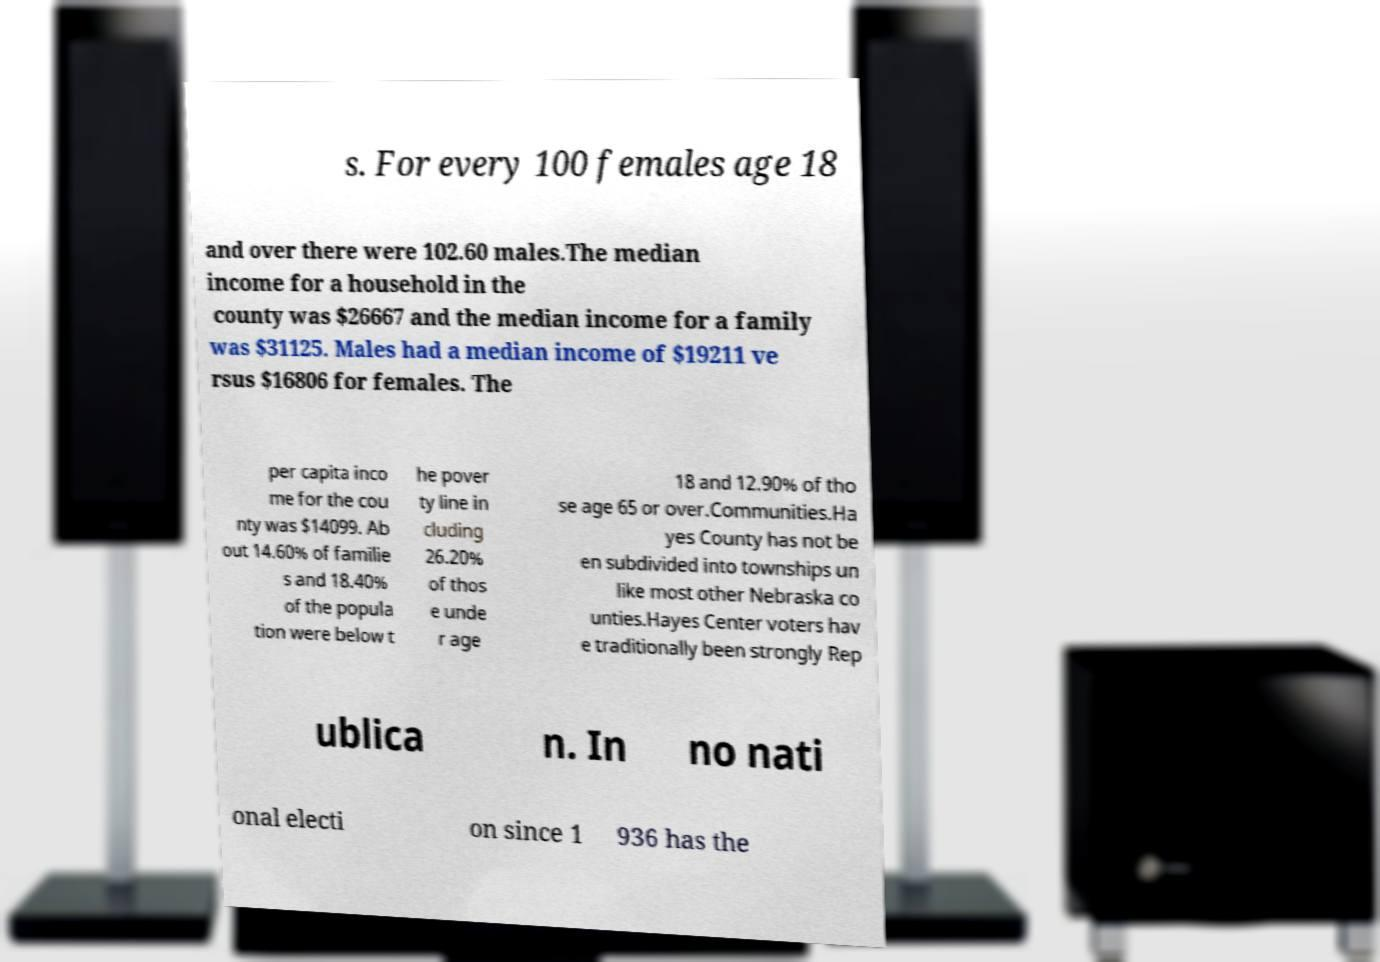Can you read and provide the text displayed in the image?This photo seems to have some interesting text. Can you extract and type it out for me? s. For every 100 females age 18 and over there were 102.60 males.The median income for a household in the county was $26667 and the median income for a family was $31125. Males had a median income of $19211 ve rsus $16806 for females. The per capita inco me for the cou nty was $14099. Ab out 14.60% of familie s and 18.40% of the popula tion were below t he pover ty line in cluding 26.20% of thos e unde r age 18 and 12.90% of tho se age 65 or over.Communities.Ha yes County has not be en subdivided into townships un like most other Nebraska co unties.Hayes Center voters hav e traditionally been strongly Rep ublica n. In no nati onal electi on since 1 936 has the 